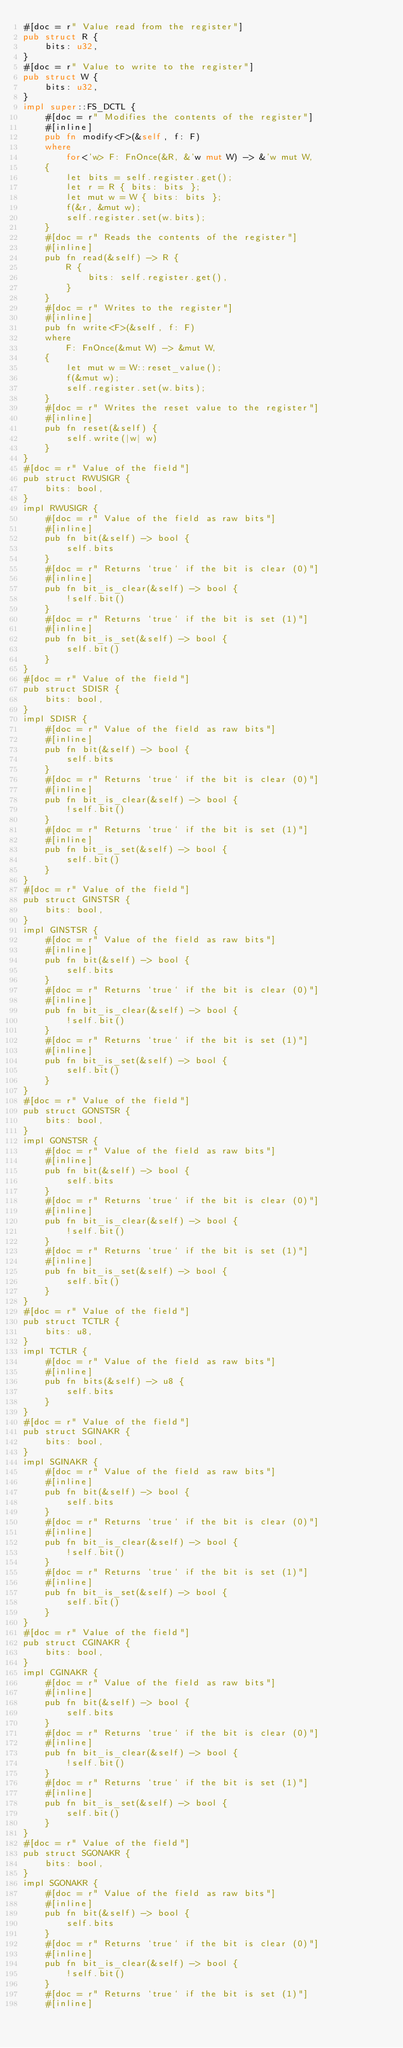<code> <loc_0><loc_0><loc_500><loc_500><_Rust_>#[doc = r" Value read from the register"]
pub struct R {
    bits: u32,
}
#[doc = r" Value to write to the register"]
pub struct W {
    bits: u32,
}
impl super::FS_DCTL {
    #[doc = r" Modifies the contents of the register"]
    #[inline]
    pub fn modify<F>(&self, f: F)
    where
        for<'w> F: FnOnce(&R, &'w mut W) -> &'w mut W,
    {
        let bits = self.register.get();
        let r = R { bits: bits };
        let mut w = W { bits: bits };
        f(&r, &mut w);
        self.register.set(w.bits);
    }
    #[doc = r" Reads the contents of the register"]
    #[inline]
    pub fn read(&self) -> R {
        R {
            bits: self.register.get(),
        }
    }
    #[doc = r" Writes to the register"]
    #[inline]
    pub fn write<F>(&self, f: F)
    where
        F: FnOnce(&mut W) -> &mut W,
    {
        let mut w = W::reset_value();
        f(&mut w);
        self.register.set(w.bits);
    }
    #[doc = r" Writes the reset value to the register"]
    #[inline]
    pub fn reset(&self) {
        self.write(|w| w)
    }
}
#[doc = r" Value of the field"]
pub struct RWUSIGR {
    bits: bool,
}
impl RWUSIGR {
    #[doc = r" Value of the field as raw bits"]
    #[inline]
    pub fn bit(&self) -> bool {
        self.bits
    }
    #[doc = r" Returns `true` if the bit is clear (0)"]
    #[inline]
    pub fn bit_is_clear(&self) -> bool {
        !self.bit()
    }
    #[doc = r" Returns `true` if the bit is set (1)"]
    #[inline]
    pub fn bit_is_set(&self) -> bool {
        self.bit()
    }
}
#[doc = r" Value of the field"]
pub struct SDISR {
    bits: bool,
}
impl SDISR {
    #[doc = r" Value of the field as raw bits"]
    #[inline]
    pub fn bit(&self) -> bool {
        self.bits
    }
    #[doc = r" Returns `true` if the bit is clear (0)"]
    #[inline]
    pub fn bit_is_clear(&self) -> bool {
        !self.bit()
    }
    #[doc = r" Returns `true` if the bit is set (1)"]
    #[inline]
    pub fn bit_is_set(&self) -> bool {
        self.bit()
    }
}
#[doc = r" Value of the field"]
pub struct GINSTSR {
    bits: bool,
}
impl GINSTSR {
    #[doc = r" Value of the field as raw bits"]
    #[inline]
    pub fn bit(&self) -> bool {
        self.bits
    }
    #[doc = r" Returns `true` if the bit is clear (0)"]
    #[inline]
    pub fn bit_is_clear(&self) -> bool {
        !self.bit()
    }
    #[doc = r" Returns `true` if the bit is set (1)"]
    #[inline]
    pub fn bit_is_set(&self) -> bool {
        self.bit()
    }
}
#[doc = r" Value of the field"]
pub struct GONSTSR {
    bits: bool,
}
impl GONSTSR {
    #[doc = r" Value of the field as raw bits"]
    #[inline]
    pub fn bit(&self) -> bool {
        self.bits
    }
    #[doc = r" Returns `true` if the bit is clear (0)"]
    #[inline]
    pub fn bit_is_clear(&self) -> bool {
        !self.bit()
    }
    #[doc = r" Returns `true` if the bit is set (1)"]
    #[inline]
    pub fn bit_is_set(&self) -> bool {
        self.bit()
    }
}
#[doc = r" Value of the field"]
pub struct TCTLR {
    bits: u8,
}
impl TCTLR {
    #[doc = r" Value of the field as raw bits"]
    #[inline]
    pub fn bits(&self) -> u8 {
        self.bits
    }
}
#[doc = r" Value of the field"]
pub struct SGINAKR {
    bits: bool,
}
impl SGINAKR {
    #[doc = r" Value of the field as raw bits"]
    #[inline]
    pub fn bit(&self) -> bool {
        self.bits
    }
    #[doc = r" Returns `true` if the bit is clear (0)"]
    #[inline]
    pub fn bit_is_clear(&self) -> bool {
        !self.bit()
    }
    #[doc = r" Returns `true` if the bit is set (1)"]
    #[inline]
    pub fn bit_is_set(&self) -> bool {
        self.bit()
    }
}
#[doc = r" Value of the field"]
pub struct CGINAKR {
    bits: bool,
}
impl CGINAKR {
    #[doc = r" Value of the field as raw bits"]
    #[inline]
    pub fn bit(&self) -> bool {
        self.bits
    }
    #[doc = r" Returns `true` if the bit is clear (0)"]
    #[inline]
    pub fn bit_is_clear(&self) -> bool {
        !self.bit()
    }
    #[doc = r" Returns `true` if the bit is set (1)"]
    #[inline]
    pub fn bit_is_set(&self) -> bool {
        self.bit()
    }
}
#[doc = r" Value of the field"]
pub struct SGONAKR {
    bits: bool,
}
impl SGONAKR {
    #[doc = r" Value of the field as raw bits"]
    #[inline]
    pub fn bit(&self) -> bool {
        self.bits
    }
    #[doc = r" Returns `true` if the bit is clear (0)"]
    #[inline]
    pub fn bit_is_clear(&self) -> bool {
        !self.bit()
    }
    #[doc = r" Returns `true` if the bit is set (1)"]
    #[inline]</code> 